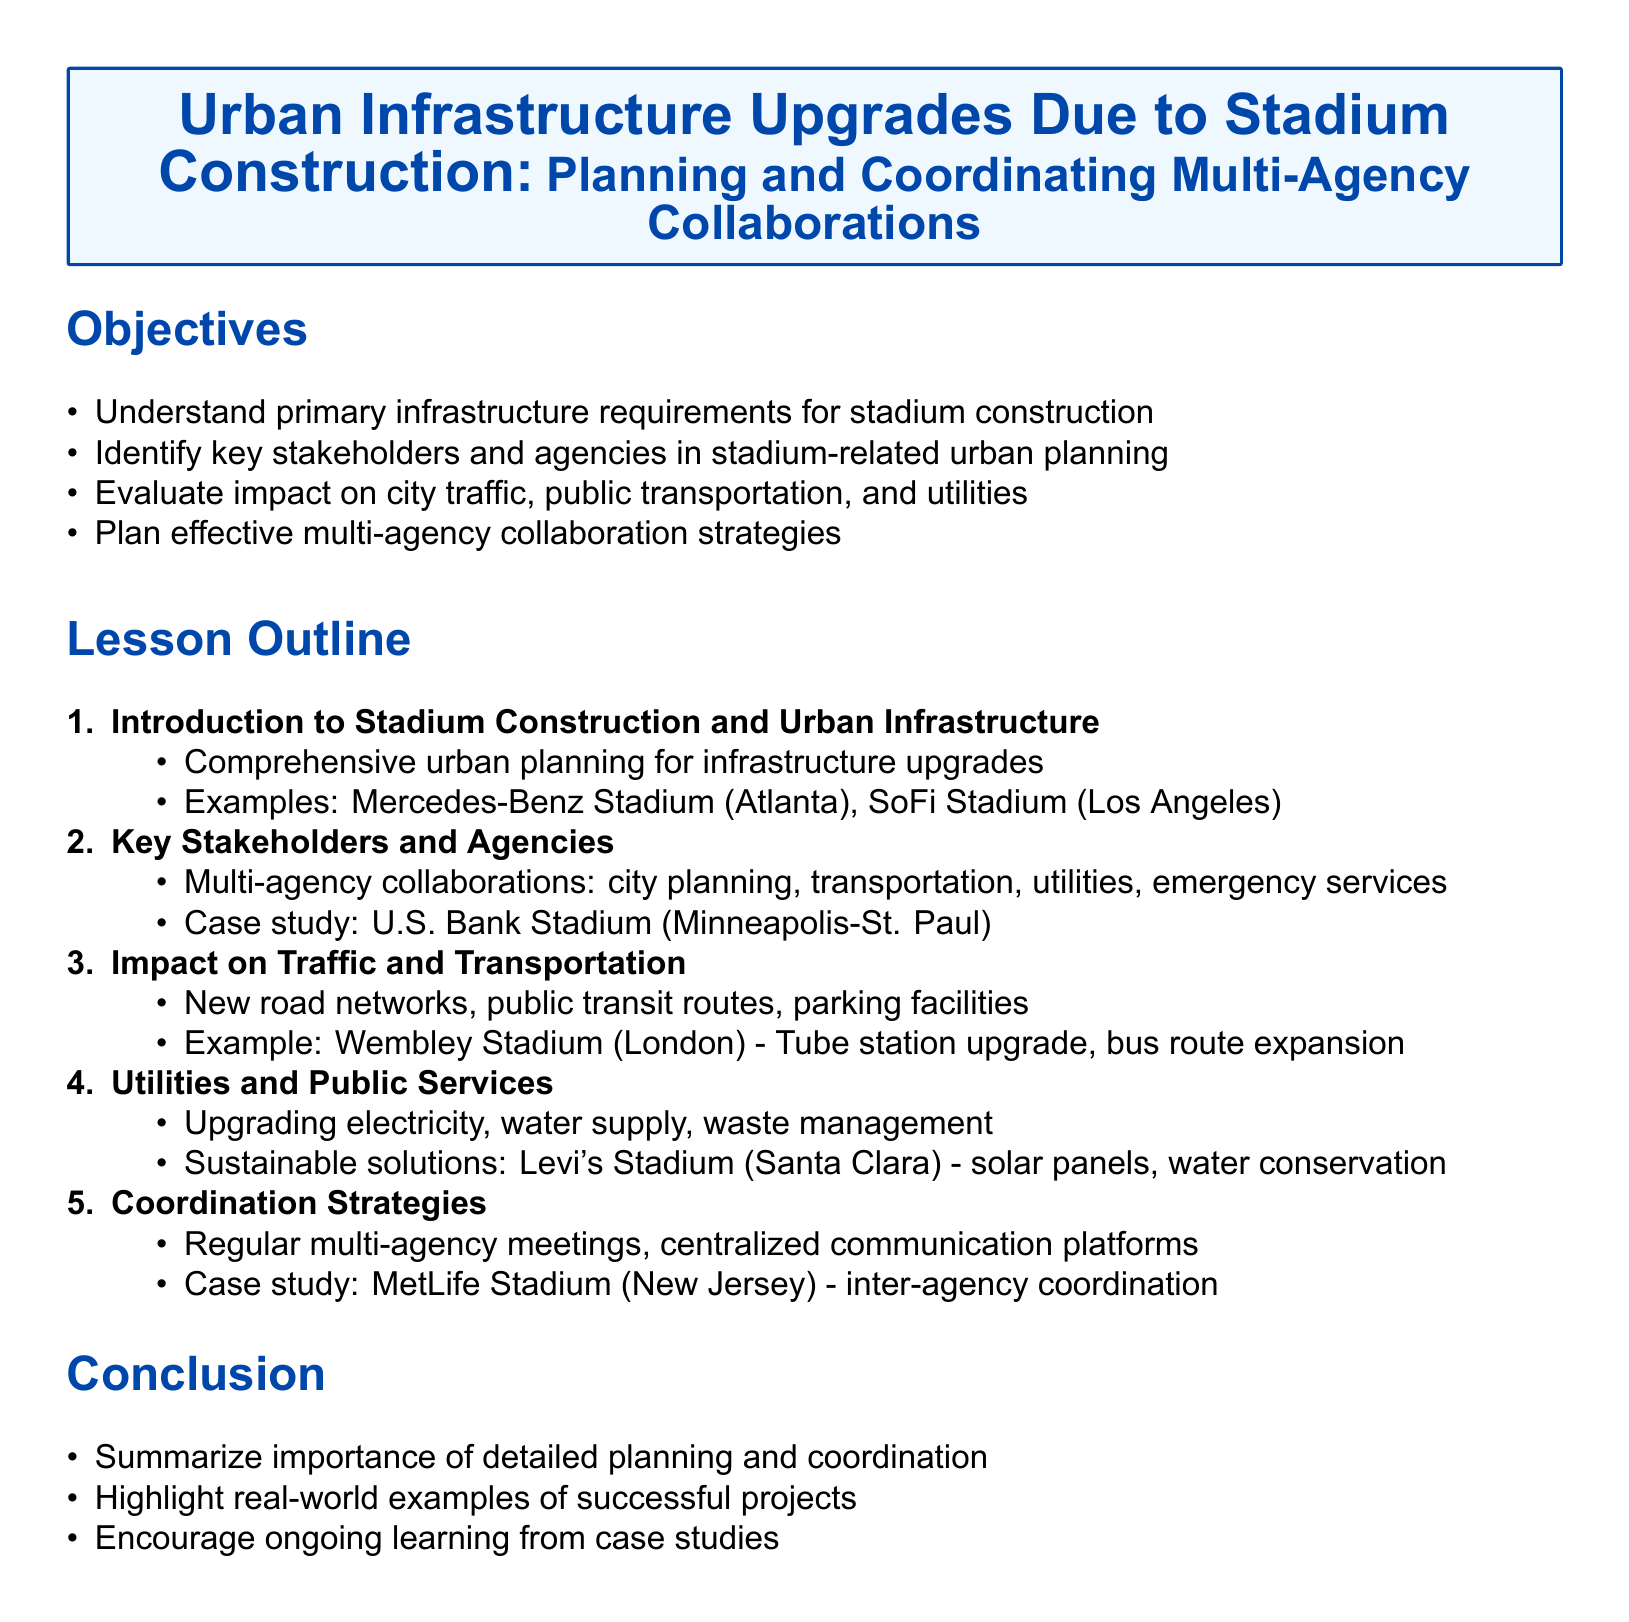What are the primary infrastructure requirements for stadium construction? The document outlines the primary infrastructure requirements in the objectives section.
Answer: Infrastructure requirements Who are the key stakeholders mentioned for stadium-related urban planning? The stakeholders are listed in the lesson outline under key stakeholders and agencies.
Answer: City planning, transportation, utilities, emergency services Which stadium is cited as a case study for multi-agency collaborations? The specific stadium is mentioned in the key stakeholders and agencies section.
Answer: U.S. Bank Stadium What is one example of a sustainable solution mentioned in the utilities and public services section? The sustainable solution is detailed in the utilities and public services lesson outline.
Answer: Solar panels What is a key strategy for coordination mentioned in the lesson outline? The coordination strategy is included in the coordination strategies section.
Answer: Regular multi-agency meetings How many main sections are listed in the lesson outline? The total number of main sections can be found by counting the numbered items in the lesson outline.
Answer: Five What is the example stadium mentioned for traffic and transportation impact? The example is provided in the impact on traffic and transportation section.
Answer: Wembley Stadium What is the last point mentioned in the conclusion? The last point is summarized in the conclusion section.
Answer: Encourage ongoing learning from case studies 